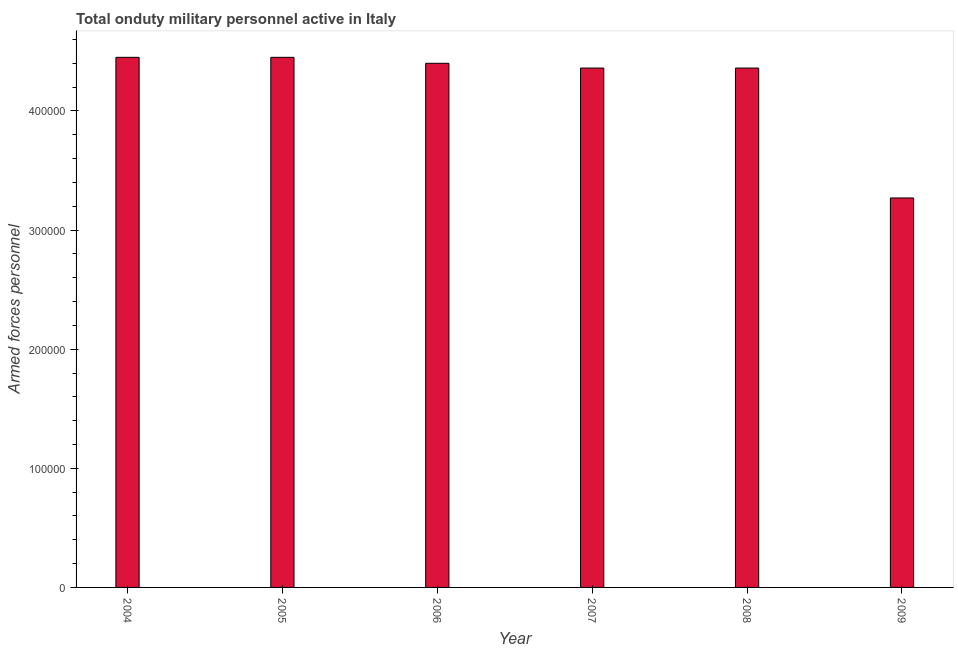Does the graph contain any zero values?
Give a very brief answer. No. What is the title of the graph?
Make the answer very short. Total onduty military personnel active in Italy. What is the label or title of the X-axis?
Provide a succinct answer. Year. What is the label or title of the Y-axis?
Make the answer very short. Armed forces personnel. What is the number of armed forces personnel in 2004?
Give a very brief answer. 4.45e+05. Across all years, what is the maximum number of armed forces personnel?
Your answer should be very brief. 4.45e+05. Across all years, what is the minimum number of armed forces personnel?
Ensure brevity in your answer.  3.27e+05. In which year was the number of armed forces personnel maximum?
Provide a short and direct response. 2004. In which year was the number of armed forces personnel minimum?
Your answer should be very brief. 2009. What is the sum of the number of armed forces personnel?
Ensure brevity in your answer.  2.53e+06. What is the difference between the number of armed forces personnel in 2004 and 2005?
Provide a succinct answer. 0. What is the average number of armed forces personnel per year?
Your response must be concise. 4.21e+05. What is the median number of armed forces personnel?
Offer a very short reply. 4.38e+05. Do a majority of the years between 2008 and 2007 (inclusive) have number of armed forces personnel greater than 360000 ?
Your answer should be very brief. No. What is the ratio of the number of armed forces personnel in 2004 to that in 2005?
Keep it short and to the point. 1. Is the difference between the number of armed forces personnel in 2005 and 2006 greater than the difference between any two years?
Make the answer very short. No. Is the sum of the number of armed forces personnel in 2004 and 2006 greater than the maximum number of armed forces personnel across all years?
Offer a terse response. Yes. What is the difference between the highest and the lowest number of armed forces personnel?
Provide a short and direct response. 1.18e+05. How many bars are there?
Offer a very short reply. 6. Are all the bars in the graph horizontal?
Give a very brief answer. No. Are the values on the major ticks of Y-axis written in scientific E-notation?
Your response must be concise. No. What is the Armed forces personnel in 2004?
Provide a succinct answer. 4.45e+05. What is the Armed forces personnel of 2005?
Your answer should be compact. 4.45e+05. What is the Armed forces personnel of 2006?
Offer a very short reply. 4.40e+05. What is the Armed forces personnel of 2007?
Your response must be concise. 4.36e+05. What is the Armed forces personnel of 2008?
Make the answer very short. 4.36e+05. What is the Armed forces personnel of 2009?
Ensure brevity in your answer.  3.27e+05. What is the difference between the Armed forces personnel in 2004 and 2005?
Your answer should be very brief. 0. What is the difference between the Armed forces personnel in 2004 and 2006?
Your answer should be very brief. 5000. What is the difference between the Armed forces personnel in 2004 and 2007?
Your response must be concise. 9000. What is the difference between the Armed forces personnel in 2004 and 2008?
Provide a short and direct response. 9000. What is the difference between the Armed forces personnel in 2004 and 2009?
Ensure brevity in your answer.  1.18e+05. What is the difference between the Armed forces personnel in 2005 and 2006?
Make the answer very short. 5000. What is the difference between the Armed forces personnel in 2005 and 2007?
Ensure brevity in your answer.  9000. What is the difference between the Armed forces personnel in 2005 and 2008?
Provide a short and direct response. 9000. What is the difference between the Armed forces personnel in 2005 and 2009?
Ensure brevity in your answer.  1.18e+05. What is the difference between the Armed forces personnel in 2006 and 2007?
Ensure brevity in your answer.  4000. What is the difference between the Armed forces personnel in 2006 and 2008?
Keep it short and to the point. 4000. What is the difference between the Armed forces personnel in 2006 and 2009?
Offer a terse response. 1.13e+05. What is the difference between the Armed forces personnel in 2007 and 2009?
Keep it short and to the point. 1.09e+05. What is the difference between the Armed forces personnel in 2008 and 2009?
Keep it short and to the point. 1.09e+05. What is the ratio of the Armed forces personnel in 2004 to that in 2005?
Your answer should be very brief. 1. What is the ratio of the Armed forces personnel in 2004 to that in 2006?
Offer a very short reply. 1.01. What is the ratio of the Armed forces personnel in 2004 to that in 2007?
Provide a succinct answer. 1.02. What is the ratio of the Armed forces personnel in 2004 to that in 2008?
Provide a short and direct response. 1.02. What is the ratio of the Armed forces personnel in 2004 to that in 2009?
Provide a short and direct response. 1.36. What is the ratio of the Armed forces personnel in 2005 to that in 2007?
Your answer should be very brief. 1.02. What is the ratio of the Armed forces personnel in 2005 to that in 2008?
Provide a short and direct response. 1.02. What is the ratio of the Armed forces personnel in 2005 to that in 2009?
Your response must be concise. 1.36. What is the ratio of the Armed forces personnel in 2006 to that in 2009?
Your answer should be very brief. 1.35. What is the ratio of the Armed forces personnel in 2007 to that in 2008?
Keep it short and to the point. 1. What is the ratio of the Armed forces personnel in 2007 to that in 2009?
Your answer should be very brief. 1.33. What is the ratio of the Armed forces personnel in 2008 to that in 2009?
Your answer should be very brief. 1.33. 